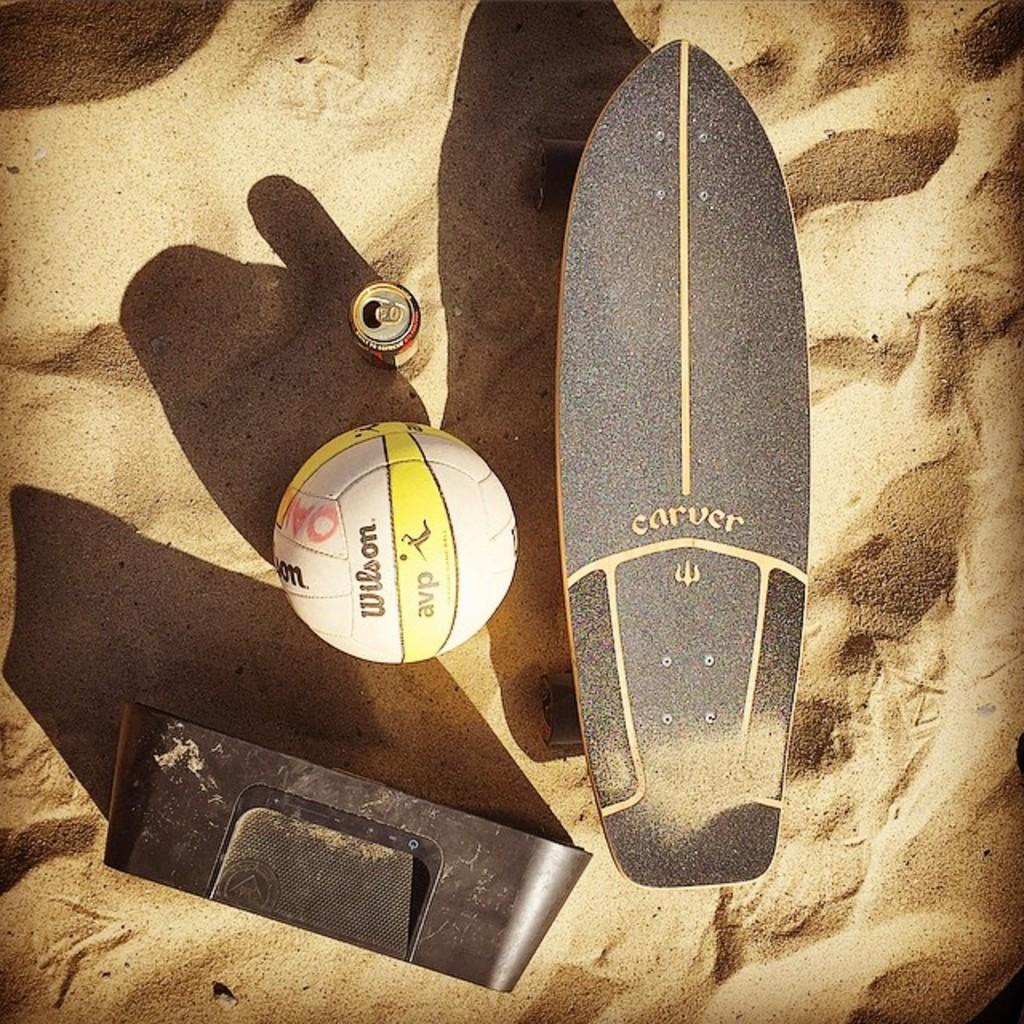What object can be seen in the image that is typically used for playing games or sports? There is a ball in the image that is typically used for playing games or sports. What type of container is present in the image? There is a tin in the image, which is a type of container. What mode of transportation is visible in the image? There is a Longboard in the image, which is a type of transportation. What is the background of the image made up of? There is sand visible in the background of the image. How many ducks are swimming in the water near the Longboard in the image? There are no ducks or water visible in the image; it only shows a ball, tin, Longboard, container, and sand in the background. 